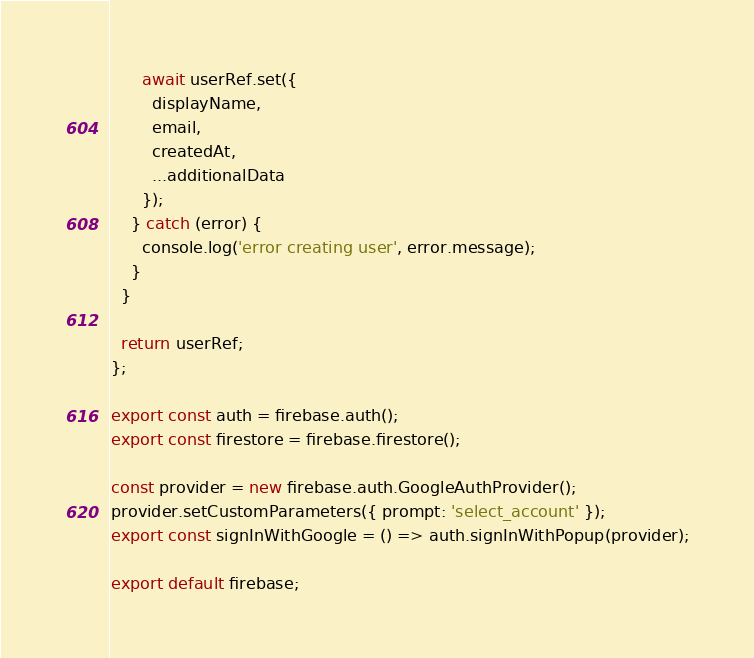<code> <loc_0><loc_0><loc_500><loc_500><_JavaScript_>      await userRef.set({
        displayName,
        email,
        createdAt,
        ...additionalData
      });
    } catch (error) {
      console.log('error creating user', error.message);
    }
  }

  return userRef;
};

export const auth = firebase.auth();
export const firestore = firebase.firestore();

const provider = new firebase.auth.GoogleAuthProvider();
provider.setCustomParameters({ prompt: 'select_account' });
export const signInWithGoogle = () => auth.signInWithPopup(provider);

export default firebase;
</code> 